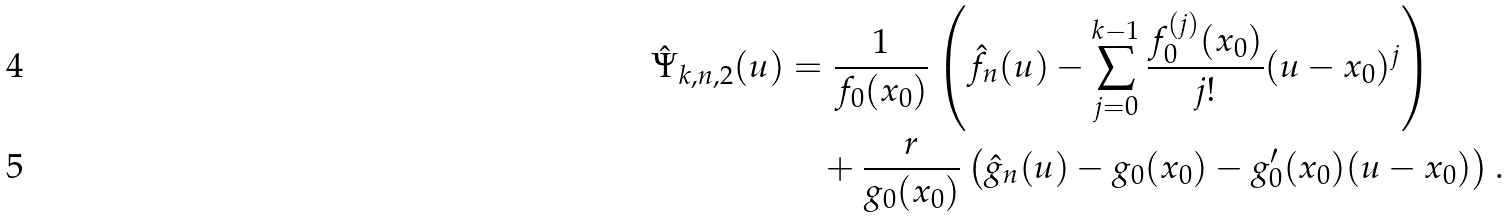<formula> <loc_0><loc_0><loc_500><loc_500>\hat { \Psi } _ { k , n , 2 } ( u ) & = \frac { 1 } { f _ { 0 } ( x _ { 0 } ) } \left ( \hat { f } _ { n } ( u ) - \sum _ { j = 0 } ^ { k - 1 } \frac { f _ { 0 } ^ { ( j ) } ( x _ { 0 } ) } { j ! } ( u - x _ { 0 } ) ^ { j } \right ) \\ & \quad + \frac { r } { g _ { 0 } ( x _ { 0 } ) } \left ( \hat { g } _ { n } ( u ) - g _ { 0 } ( x _ { 0 } ) - g _ { 0 } ^ { \prime } ( x _ { 0 } ) ( u - x _ { 0 } ) \right ) .</formula> 